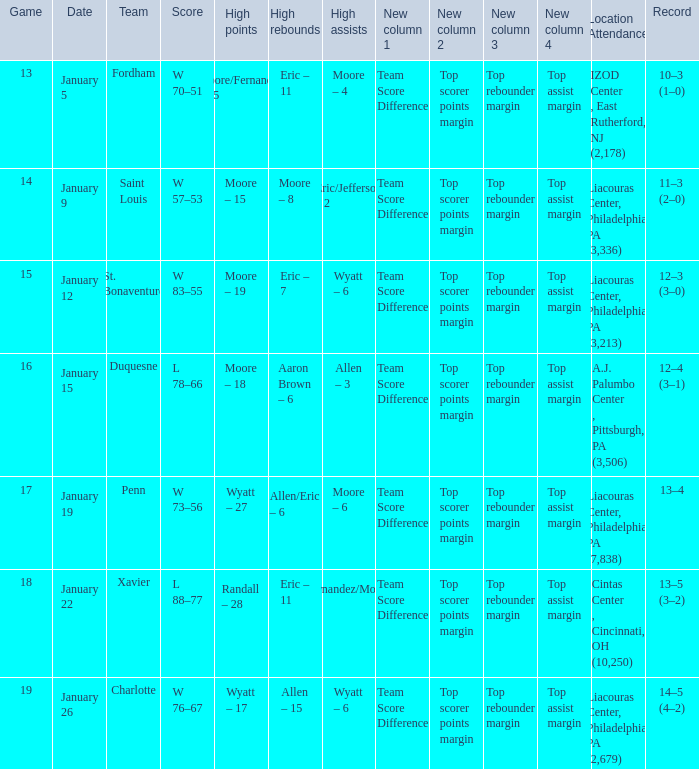Could you help me parse every detail presented in this table? {'header': ['Game', 'Date', 'Team', 'Score', 'High points', 'High rebounds', 'High assists', 'New column 1', 'New column 2', 'New column 3', 'New column 4', 'Location Attendance', 'Record'], 'rows': [['13', 'January 5', 'Fordham', 'W 70–51', 'Moore/Fernandez – 15', 'Eric – 11', 'Moore – 4', 'Team Score Difference', 'Top scorer points margin', 'Top rebounder margin', 'Top assist margin', 'IZOD Center , East Rutherford, NJ (2,178)', '10–3 (1–0)'], ['14', 'January 9', 'Saint Louis', 'W 57–53', 'Moore – 15', 'Moore – 8', 'Eric/Jefferson – 2', 'Team Score Difference', 'Top scorer points margin', 'Top rebounder margin', 'Top assist margin ', 'Liacouras Center, Philadelphia, PA (3,336)', '11–3 (2–0)'], ['15', 'January 12', 'St. Bonaventure', 'W 83–55', 'Moore – 19', 'Eric – 7', 'Wyatt – 6', 'Team Score Difference', 'Top scorer points margin', 'Top rebounder margin', 'Top assist margin', 'Liacouras Center, Philadelphia, PA (3,213)', '12–3 (3–0)'], ['16', 'January 15', 'Duquesne', 'L 78–66', 'Moore – 18', 'Aaron Brown – 6', 'Allen – 3', 'Team Score Difference', 'Top scorer points margin', 'Top rebounder margin', 'Top assist margin', 'A.J. Palumbo Center , Pittsburgh, PA (3,506)', '12–4 (3–1)'], ['17', 'January 19', 'Penn', 'W 73–56', 'Wyatt – 27', 'Allen/Eric – 6', 'Moore – 6', 'Team Score Difference', 'Top scorer points margin', 'Top rebounder margin', 'Top assist margin', 'Liacouras Center, Philadelphia, PA (7,838)', '13–4'], ['18', 'January 22', 'Xavier', 'L 88–77', 'Randall – 28', 'Eric – 11', 'Fernandez/Moore – 5', 'Team Score Difference', 'Top scorer points margin', 'Top rebounder margin', 'Top assist margin', 'Cintas Center , Cincinnati, OH (10,250)', '13–5 (3–2)'], ['19', 'January 26', 'Charlotte', 'W 76–67', 'Wyatt – 17', 'Allen – 15', 'Wyatt – 6', 'Team Score Difference', 'Top scorer points margin', 'Top rebounder margin', 'Top assist margin', 'Liacouras Center, Philadelphia, PA (2,679)', '14–5 (4–2)']]} What team was Temple playing on January 19? Penn. 